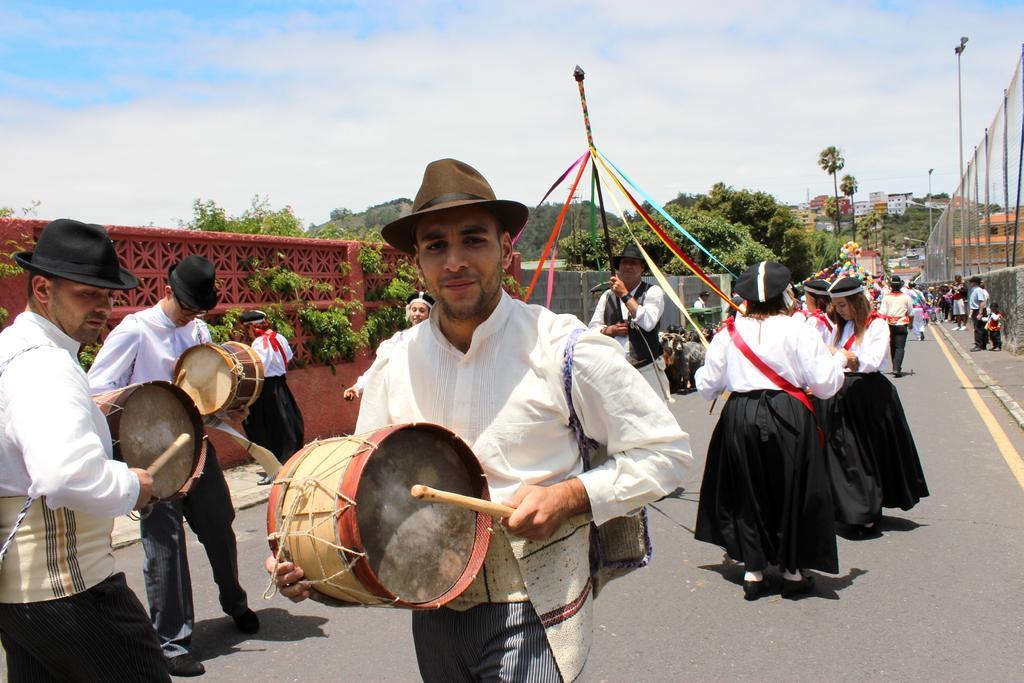Could you give a brief overview of what you see in this image? A group of people performing some program on the road. Among them three men are holding the band and playing the instrument and other guy behind him is holding a pipe like thing which had different colors of cloth ribbon like thing which is tied to it and and other women holding different color ribbons and performing and even we can see some children on the foot path and the pole which has light and some trees around them. The woman has the hat and all are in white color shirt and black color gown and men have hat and white shirt. 